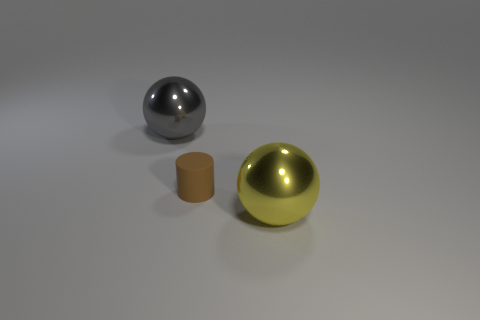Add 1 large yellow shiny objects. How many objects exist? 4 Subtract all spheres. How many objects are left? 1 Subtract all metal balls. Subtract all yellow shiny spheres. How many objects are left? 0 Add 1 big gray shiny things. How many big gray shiny things are left? 2 Add 2 red shiny things. How many red shiny things exist? 2 Subtract 0 cyan spheres. How many objects are left? 3 